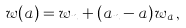Convert formula to latex. <formula><loc_0><loc_0><loc_500><loc_500>w ( a ) = w _ { n } + ( a _ { n } - a ) w _ { a } \, ,</formula> 